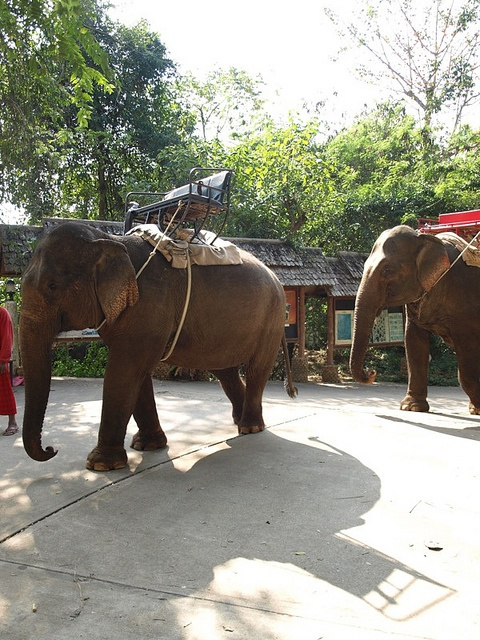Describe the objects in this image and their specific colors. I can see elephant in darkgreen, black, gray, and maroon tones, elephant in darkgreen, black, maroon, and gray tones, bench in darkgreen, gray, black, lightgray, and darkgray tones, people in darkgreen, maroon, brown, gray, and black tones, and bench in darkgreen, maroon, red, brown, and lightgray tones in this image. 